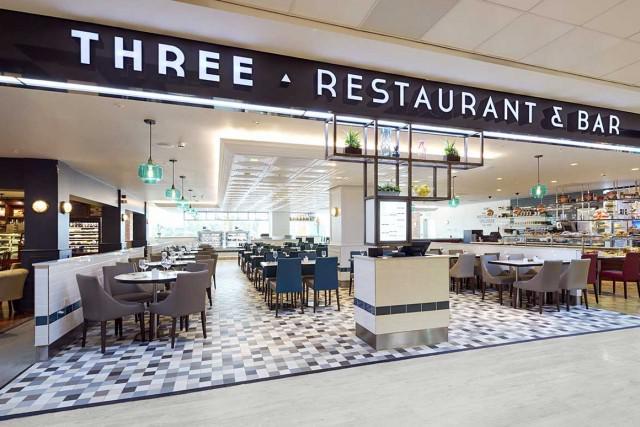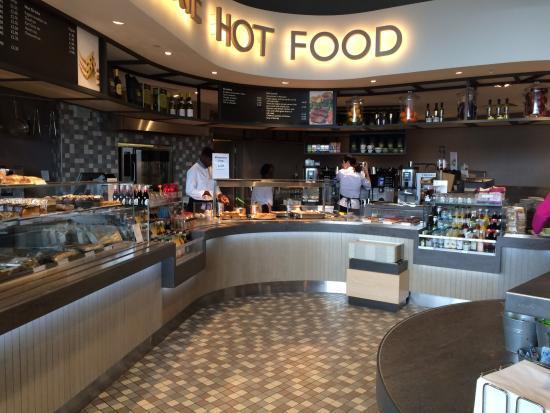The first image is the image on the left, the second image is the image on the right. For the images shown, is this caption "One image shows a restaurant with a black band running around the top, with white lettering on it, and at least one rectangular upright stand under it." true? Answer yes or no. Yes. The first image is the image on the left, the second image is the image on the right. Assess this claim about the two images: "There are people sitting in chairs in the left image.". Correct or not? Answer yes or no. No. 